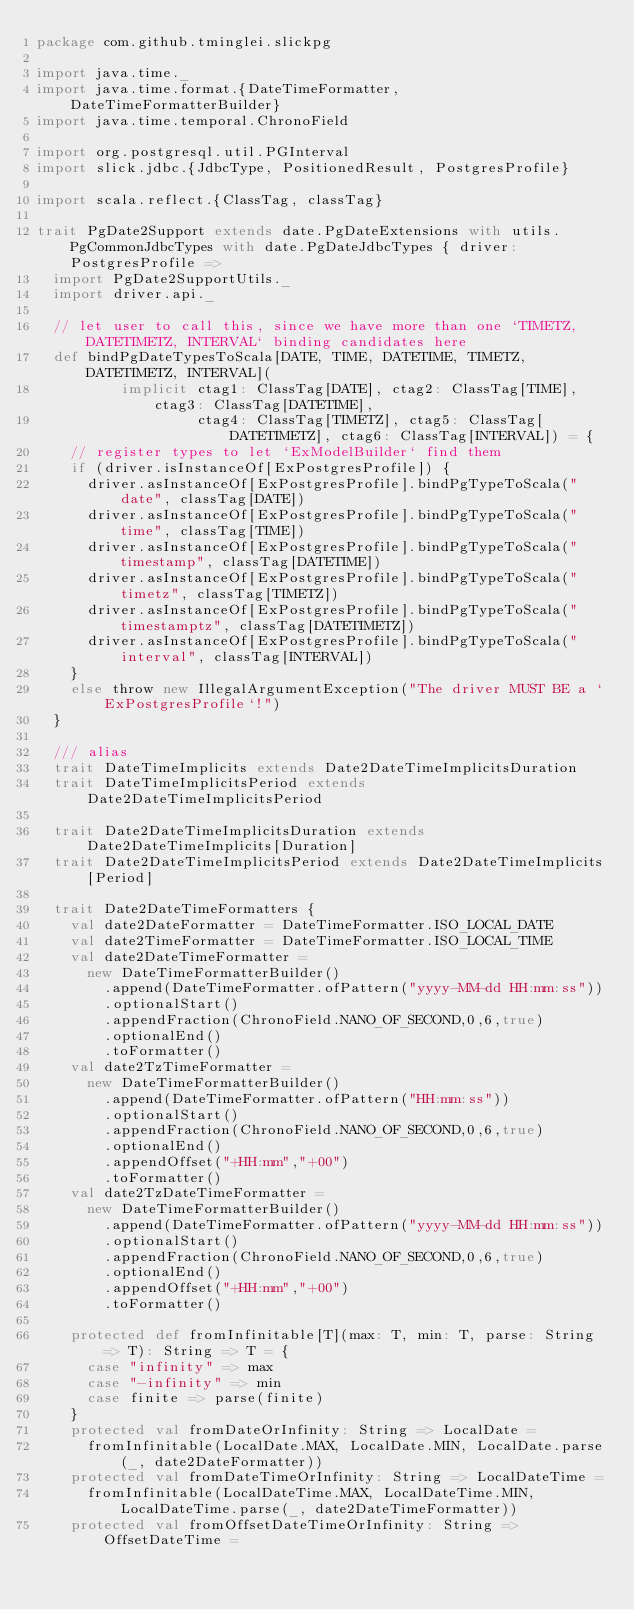<code> <loc_0><loc_0><loc_500><loc_500><_Scala_>package com.github.tminglei.slickpg

import java.time._
import java.time.format.{DateTimeFormatter, DateTimeFormatterBuilder}
import java.time.temporal.ChronoField

import org.postgresql.util.PGInterval
import slick.jdbc.{JdbcType, PositionedResult, PostgresProfile}

import scala.reflect.{ClassTag, classTag}

trait PgDate2Support extends date.PgDateExtensions with utils.PgCommonJdbcTypes with date.PgDateJdbcTypes { driver: PostgresProfile =>
  import PgDate2SupportUtils._
  import driver.api._

  // let user to call this, since we have more than one `TIMETZ, DATETIMETZ, INTERVAL` binding candidates here
  def bindPgDateTypesToScala[DATE, TIME, DATETIME, TIMETZ, DATETIMETZ, INTERVAL](
          implicit ctag1: ClassTag[DATE], ctag2: ClassTag[TIME], ctag3: ClassTag[DATETIME],
                   ctag4: ClassTag[TIMETZ], ctag5: ClassTag[DATETIMETZ], ctag6: ClassTag[INTERVAL]) = {
    // register types to let `ExModelBuilder` find them
    if (driver.isInstanceOf[ExPostgresProfile]) {
      driver.asInstanceOf[ExPostgresProfile].bindPgTypeToScala("date", classTag[DATE])
      driver.asInstanceOf[ExPostgresProfile].bindPgTypeToScala("time", classTag[TIME])
      driver.asInstanceOf[ExPostgresProfile].bindPgTypeToScala("timestamp", classTag[DATETIME])
      driver.asInstanceOf[ExPostgresProfile].bindPgTypeToScala("timetz", classTag[TIMETZ])
      driver.asInstanceOf[ExPostgresProfile].bindPgTypeToScala("timestamptz", classTag[DATETIMETZ])
      driver.asInstanceOf[ExPostgresProfile].bindPgTypeToScala("interval", classTag[INTERVAL])
    }
    else throw new IllegalArgumentException("The driver MUST BE a `ExPostgresProfile`!")
  }

  /// alias
  trait DateTimeImplicits extends Date2DateTimeImplicitsDuration
  trait DateTimeImplicitsPeriod extends Date2DateTimeImplicitsPeriod

  trait Date2DateTimeImplicitsDuration extends Date2DateTimeImplicits[Duration]
  trait Date2DateTimeImplicitsPeriod extends Date2DateTimeImplicits[Period]

  trait Date2DateTimeFormatters {
    val date2DateFormatter = DateTimeFormatter.ISO_LOCAL_DATE
    val date2TimeFormatter = DateTimeFormatter.ISO_LOCAL_TIME
    val date2DateTimeFormatter =
      new DateTimeFormatterBuilder()
        .append(DateTimeFormatter.ofPattern("yyyy-MM-dd HH:mm:ss"))
        .optionalStart()
        .appendFraction(ChronoField.NANO_OF_SECOND,0,6,true)
        .optionalEnd()
        .toFormatter()
    val date2TzTimeFormatter =
      new DateTimeFormatterBuilder()
        .append(DateTimeFormatter.ofPattern("HH:mm:ss"))
        .optionalStart()
        .appendFraction(ChronoField.NANO_OF_SECOND,0,6,true)
        .optionalEnd()
        .appendOffset("+HH:mm","+00")
        .toFormatter()
    val date2TzDateTimeFormatter =
      new DateTimeFormatterBuilder()
        .append(DateTimeFormatter.ofPattern("yyyy-MM-dd HH:mm:ss"))
        .optionalStart()
        .appendFraction(ChronoField.NANO_OF_SECOND,0,6,true)
        .optionalEnd()
        .appendOffset("+HH:mm","+00")
        .toFormatter()

    protected def fromInfinitable[T](max: T, min: T, parse: String => T): String => T = {
      case "infinity" => max
      case "-infinity" => min
      case finite => parse(finite)
    }
    protected val fromDateOrInfinity: String => LocalDate =
      fromInfinitable(LocalDate.MAX, LocalDate.MIN, LocalDate.parse(_, date2DateFormatter))
    protected val fromDateTimeOrInfinity: String => LocalDateTime =
      fromInfinitable(LocalDateTime.MAX, LocalDateTime.MIN, LocalDateTime.parse(_, date2DateTimeFormatter))
    protected val fromOffsetDateTimeOrInfinity: String => OffsetDateTime =</code> 